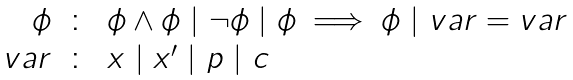<formula> <loc_0><loc_0><loc_500><loc_500>\begin{array} { r c l } \phi & \colon & \phi \wedge \phi \ | \ \neg \phi \ | \ \phi \implies \phi \ | \ v a r = v a r \\ v a r & \colon & x \ | \ x ^ { \prime } \ | \ p \ | \ c \end{array}</formula> 